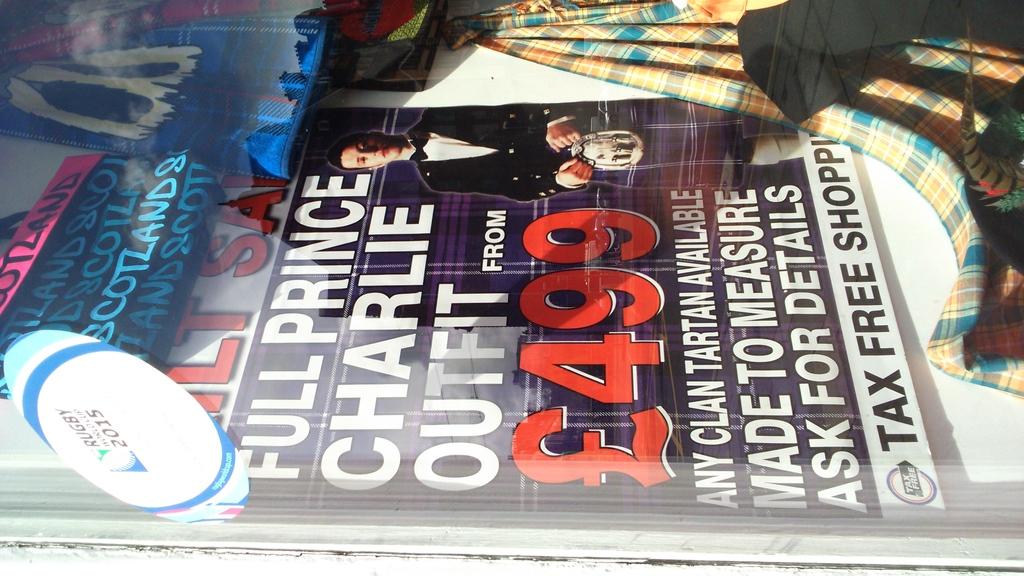How much did the outfit cost?
Offer a very short reply. 499. What is the price on the sign?
Ensure brevity in your answer.  499. 